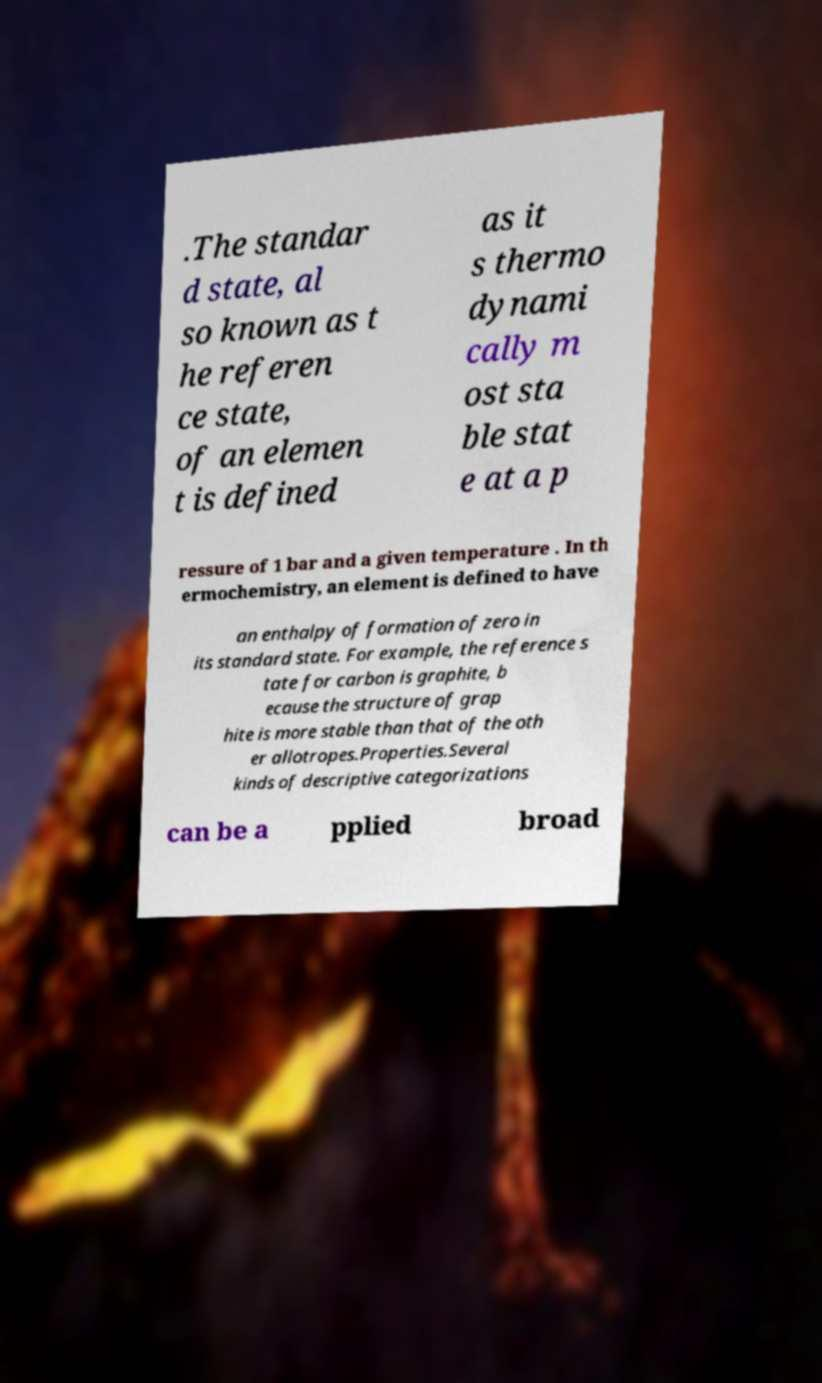There's text embedded in this image that I need extracted. Can you transcribe it verbatim? .The standar d state, al so known as t he referen ce state, of an elemen t is defined as it s thermo dynami cally m ost sta ble stat e at a p ressure of 1 bar and a given temperature . In th ermochemistry, an element is defined to have an enthalpy of formation of zero in its standard state. For example, the reference s tate for carbon is graphite, b ecause the structure of grap hite is more stable than that of the oth er allotropes.Properties.Several kinds of descriptive categorizations can be a pplied broad 